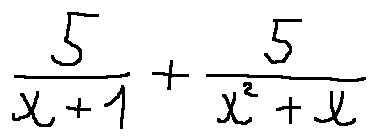Convert formula to latex. <formula><loc_0><loc_0><loc_500><loc_500>\frac { 5 } { x + 1 } + \frac { 5 } { x ^ { 2 } + x }</formula> 